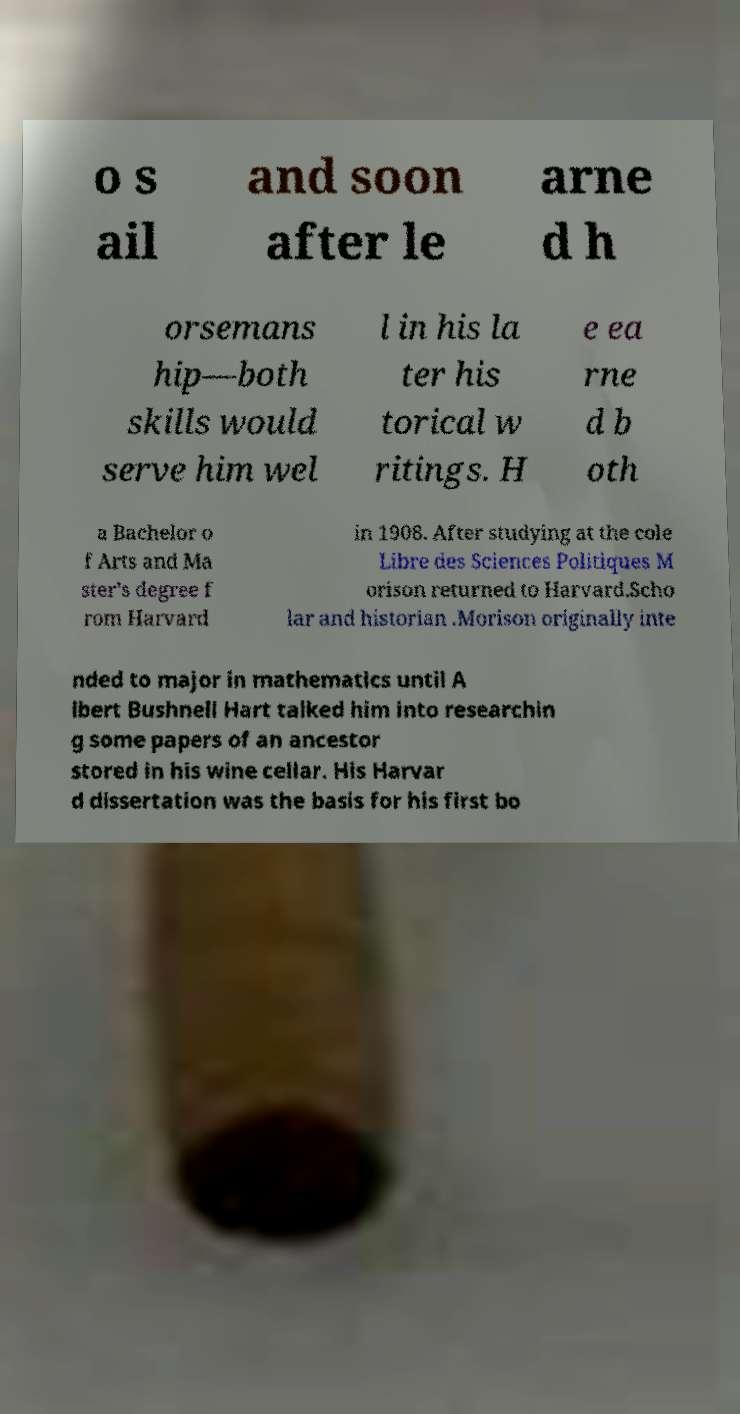There's text embedded in this image that I need extracted. Can you transcribe it verbatim? o s ail and soon after le arne d h orsemans hip—both skills would serve him wel l in his la ter his torical w ritings. H e ea rne d b oth a Bachelor o f Arts and Ma ster's degree f rom Harvard in 1908. After studying at the cole Libre des Sciences Politiques M orison returned to Harvard.Scho lar and historian .Morison originally inte nded to major in mathematics until A lbert Bushnell Hart talked him into researchin g some papers of an ancestor stored in his wine cellar. His Harvar d dissertation was the basis for his first bo 